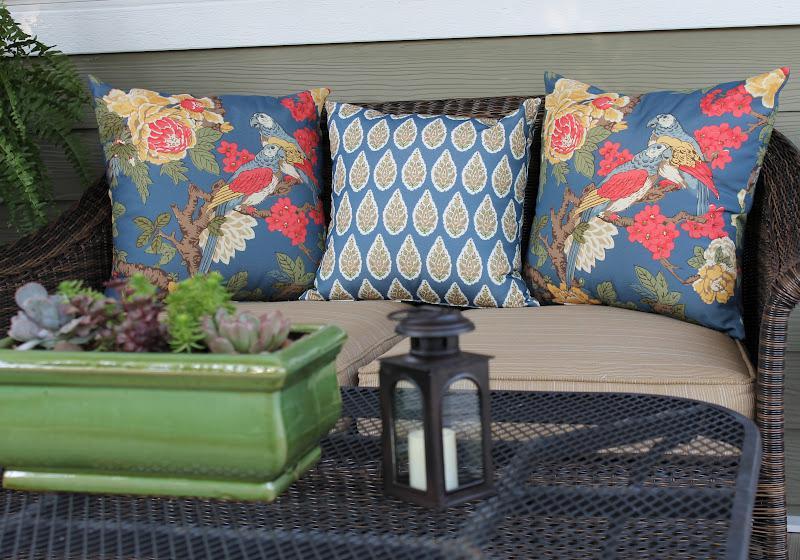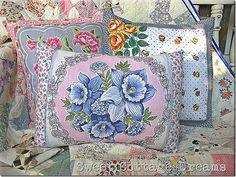The first image is the image on the left, the second image is the image on the right. Analyze the images presented: Is the assertion "There are flowers on at least one pillow in each image, and none of the pillow are fuzzy." valid? Answer yes or no. Yes. 